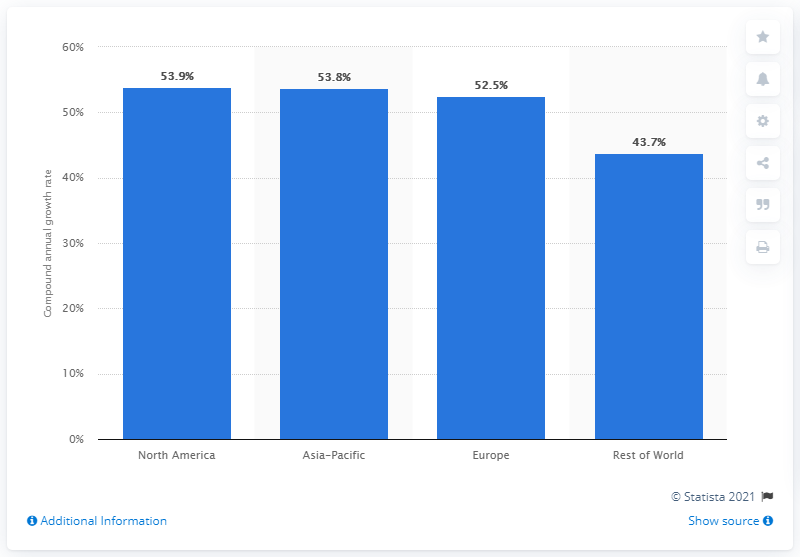Highlight a few significant elements in this photo. The compound annual growth rate (CAGR) of the North American region was 53.9% for the given period. 